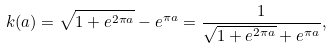<formula> <loc_0><loc_0><loc_500><loc_500>k ( a ) = \sqrt { 1 + e ^ { 2 \pi a } } - e ^ { \pi a } = \frac { 1 } { \sqrt { 1 + e ^ { 2 \pi a } } + e ^ { \pi a } } ,</formula> 